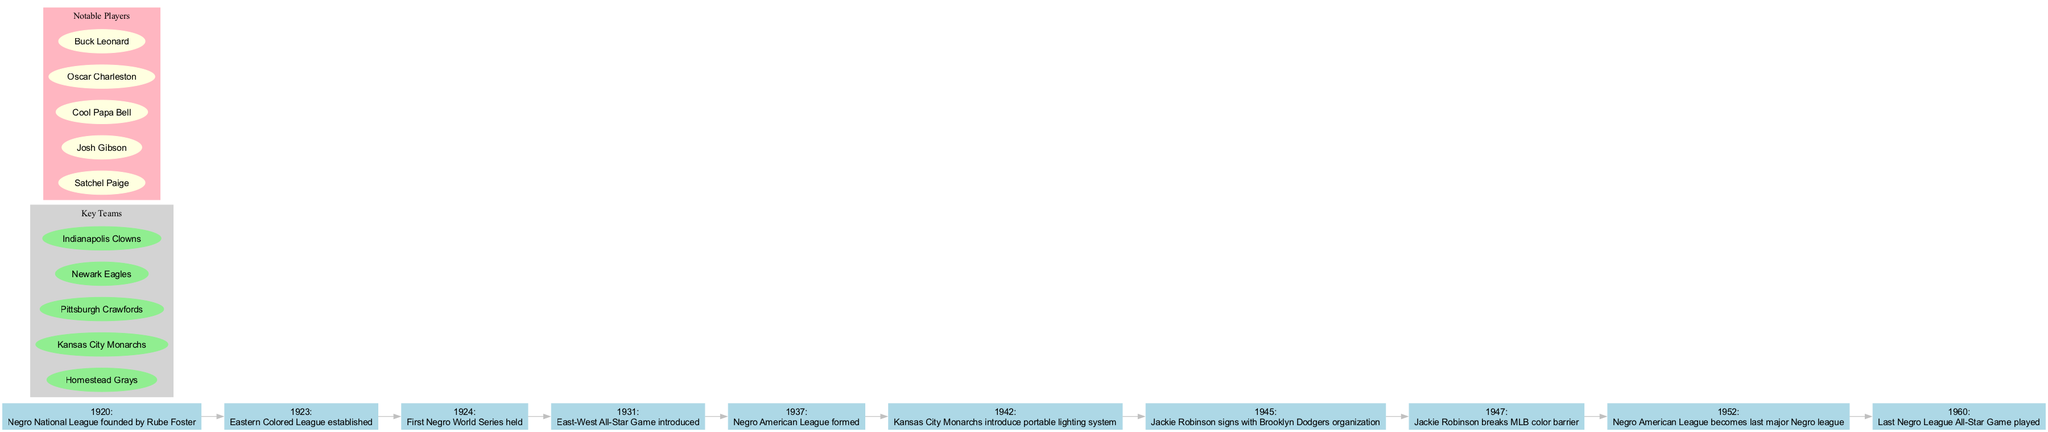What year was the Negro National League founded? The diagram indicates that the Negro National League was founded in 1920, as stated in the first event on the timeline.
Answer: 1920 Which event directly follows the establishment of the Eastern Colored League? By examining the timeline, the event that follows the establishment of the Eastern Colored League in 1923 is the first Negro World Series held in 1924.
Answer: First Negro World Series held How many major Negro leagues are identified in this timeline? The timeline shows there are three major leagues mentioned: the Negro National League, the Eastern Colored League, and the Negro American League. Counting these events provides the answer.
Answer: 3 What notable player signed with the Brooklyn Dodgers organization in 1945? The diagram highlights that in 1945, Jackie Robinson signed with the Brooklyn Dodgers organization, making him a significant event on the timeline.
Answer: Jackie Robinson Which key team was formed in 1937? Referring to the timeline, there is no formation of a new key team in 1937; instead, it records that the Negro American League was formed then.
Answer: Negro American League In what year did Jackie Robinson break the MLB color barrier? The diagram clearly states that Jackie Robinson broke the MLB color barrier in 1947, marked as a significant event in the timeline.
Answer: 1947 What is the last event recorded on the timeline? By reviewing the timeline from the start to the end, the last recorded event is the Last Negro League All-Star Game played in 1960.
Answer: Last Negro League All-Star Game played How many notable players are listed in the diagram? The diagram contains a subgraph listing five notable players associated with the Negro Leagues, which provides the answer when counted.
Answer: 5 What color is used for the nodes representing key teams? The diagram shows that the key teams are represented with nodes colored light green, as indicated in the subgraph section.
Answer: Light green 